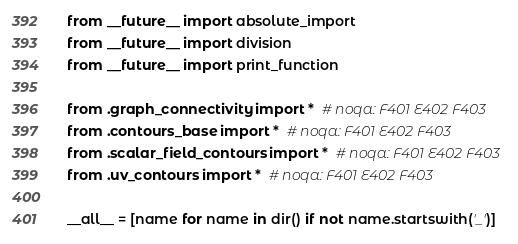Convert code to text. <code><loc_0><loc_0><loc_500><loc_500><_Python_>from __future__ import absolute_import
from __future__ import division
from __future__ import print_function

from .graph_connectivity import *  # noqa: F401 E402 F403
from .contours_base import *  # noqa: F401 E402 F403
from .scalar_field_contours import *  # noqa: F401 E402 F403
from .uv_contours import *  # noqa: F401 E402 F403

__all__ = [name for name in dir() if not name.startswith('_')]
</code> 